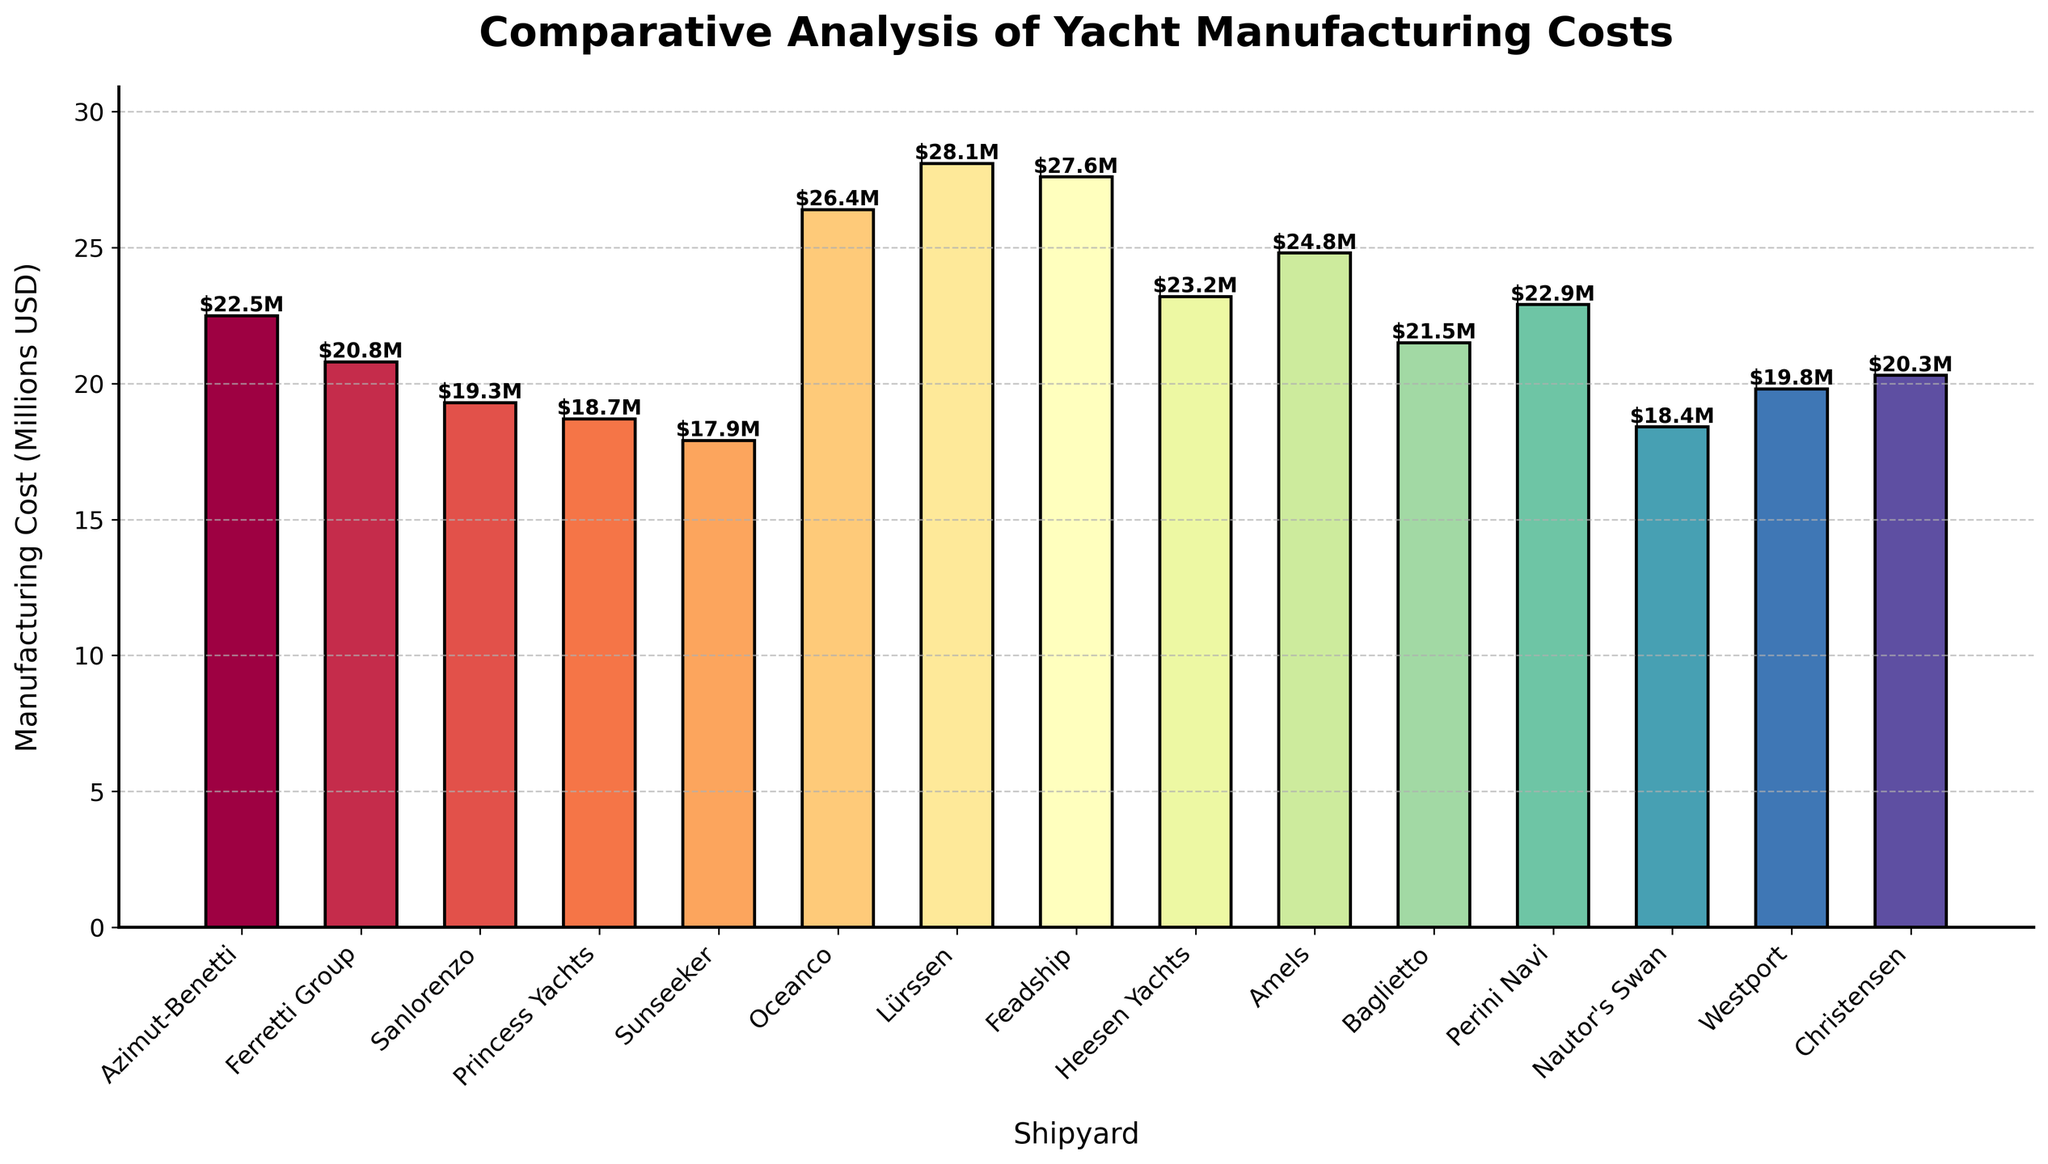What is the manufacturing cost of the most expensive yacht? The highest bar in the chart represents the most expensive yacht. By looking at the bar heights, the tallest bar corresponds to Lürssen with a cost of 28.1 million USD.
Answer: 28.1 million USD What is the sum of the manufacturing costs for Azimut-Benetti and Lürssen? First, identify the bars for Azimut-Benetti (22.5 million USD) and Lürssen (28.1 million USD). Add these two values together: 22.5 + 28.1 = 50.6 million USD.
Answer: 50.6 million USD Which shipyard has a manufacturing cost closest to 20 million USD? Look for the bar that is closest in height to 20 on the y-axis. Christensen’s bar is at 20.3 million USD, very close to 20 million USD.
Answer: Christensen How many shipyards have manufacturing costs higher than 25 million USD? Identify bars representing values greater than 25 million USD. These are Oceanco (26.4 million USD), Lürssen (28.1 million USD), and Feadship (27.6 million USD). So, there are three such shipyards.
Answer: 3 Which shipyard has a manufacturing cost lower than Sanlorenzo but higher than Princess Yachts? Sanlorenzo has a cost of 19.3 million USD, and Princess Yachts has a cost of 18.7 million USD. The shipyard between these costs is Westport, with a cost of 19.8 million USD.
Answer: Westport What is the median manufacturing cost among all shipyards? First, list the costs in ascending order: 17.9, 18.4, 18.7, 19.3, 19.8, 20.3, 20.8, 21.5, 22.5, 22.9, 23.2, 24.8, 26.4, 27.6, 28.1. The middle value in this ordered list, the 8th value, is 21.5 million USD.
Answer: 21.5 million USD What is the difference in manufacturing cost between Feadship and Baglietto? Identify the costs for Feadship (27.6 million USD) and Baglietto (21.5 million USD). Subtract Baglietto’s cost from Feadship’s cost: 27.6 - 21.5 = 6.1 million USD.
Answer: 6.1 million USD Which shipyard with a manufacturing cost over 25 million USD has the lowest cost? Identify shipyards with costs over 25 million USD: Oceanco (26.4), Lürssen (28.1), and Feadship (27.6). Among these, Oceanco has the lowest cost at 26.4 million USD.
Answer: Oceanco 